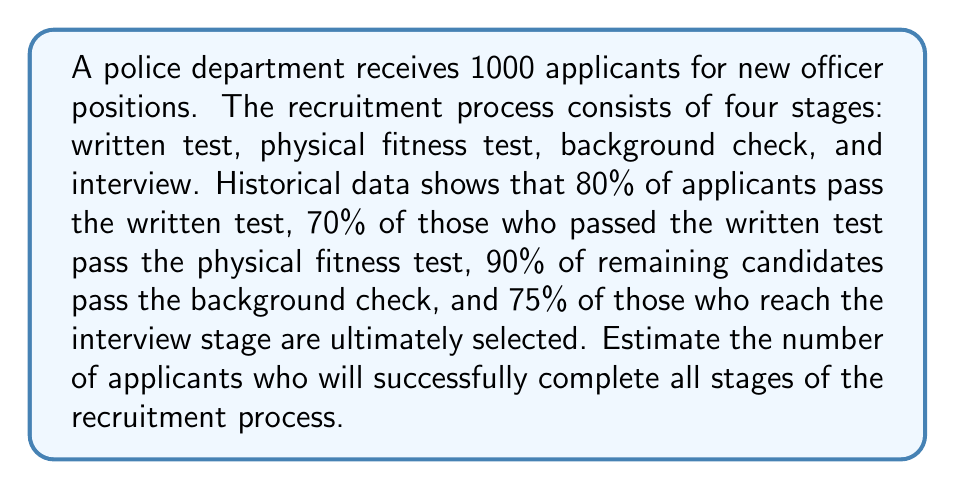Give your solution to this math problem. To solve this problem, we need to calculate the number of applicants that pass each stage sequentially:

1. Written test:
   $1000 \times 0.80 = 800$ applicants pass

2. Physical fitness test:
   $800 \times 0.70 = 560$ applicants pass

3. Background check:
   $560 \times 0.90 = 504$ applicants pass

4. Interview:
   $504 \times 0.75 = 378$ applicants pass

The final calculation can be expressed as a single equation:

$$1000 \times 0.80 \times 0.70 \times 0.90 \times 0.75 = 378$$

This can also be written as:

$$1000 \times (0.80 \times 0.70 \times 0.90 \times 0.75) = 378$$

Where $(0.80 \times 0.70 \times 0.90 \times 0.75)$ represents the overall success rate through all stages.
Answer: 378 applicants 